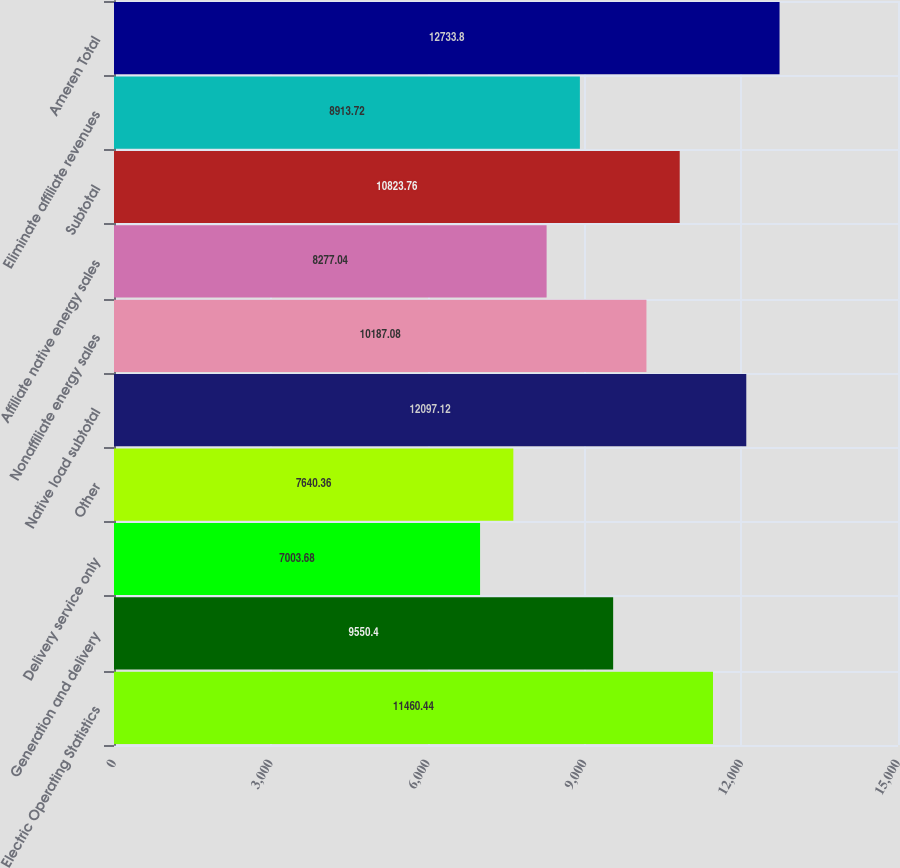Convert chart to OTSL. <chart><loc_0><loc_0><loc_500><loc_500><bar_chart><fcel>Electric Operating Statistics<fcel>Generation and delivery<fcel>Delivery service only<fcel>Other<fcel>Native load subtotal<fcel>Nonaffiliate energy sales<fcel>Affiliate native energy sales<fcel>Subtotal<fcel>Eliminate affiliate revenues<fcel>Ameren Total<nl><fcel>11460.4<fcel>9550.4<fcel>7003.68<fcel>7640.36<fcel>12097.1<fcel>10187.1<fcel>8277.04<fcel>10823.8<fcel>8913.72<fcel>12733.8<nl></chart> 